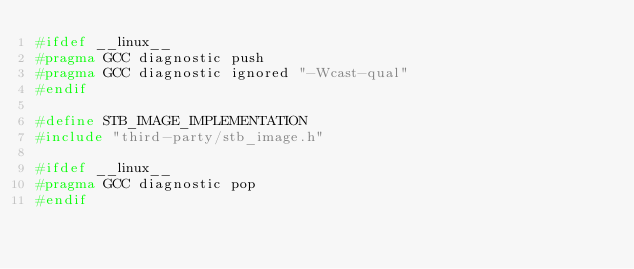Convert code to text. <code><loc_0><loc_0><loc_500><loc_500><_C++_>#ifdef __linux__
#pragma GCC diagnostic push
#pragma GCC diagnostic ignored "-Wcast-qual"
#endif

#define STB_IMAGE_IMPLEMENTATION
#include "third-party/stb_image.h"

#ifdef __linux__
#pragma GCC diagnostic pop
#endif</code> 